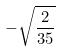Convert formula to latex. <formula><loc_0><loc_0><loc_500><loc_500>- \sqrt { \frac { 2 } { 3 5 } }</formula> 